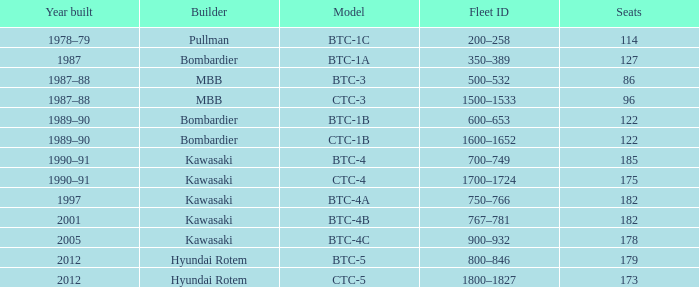In which year was the ctc-3 model constructed? 1987–88. 